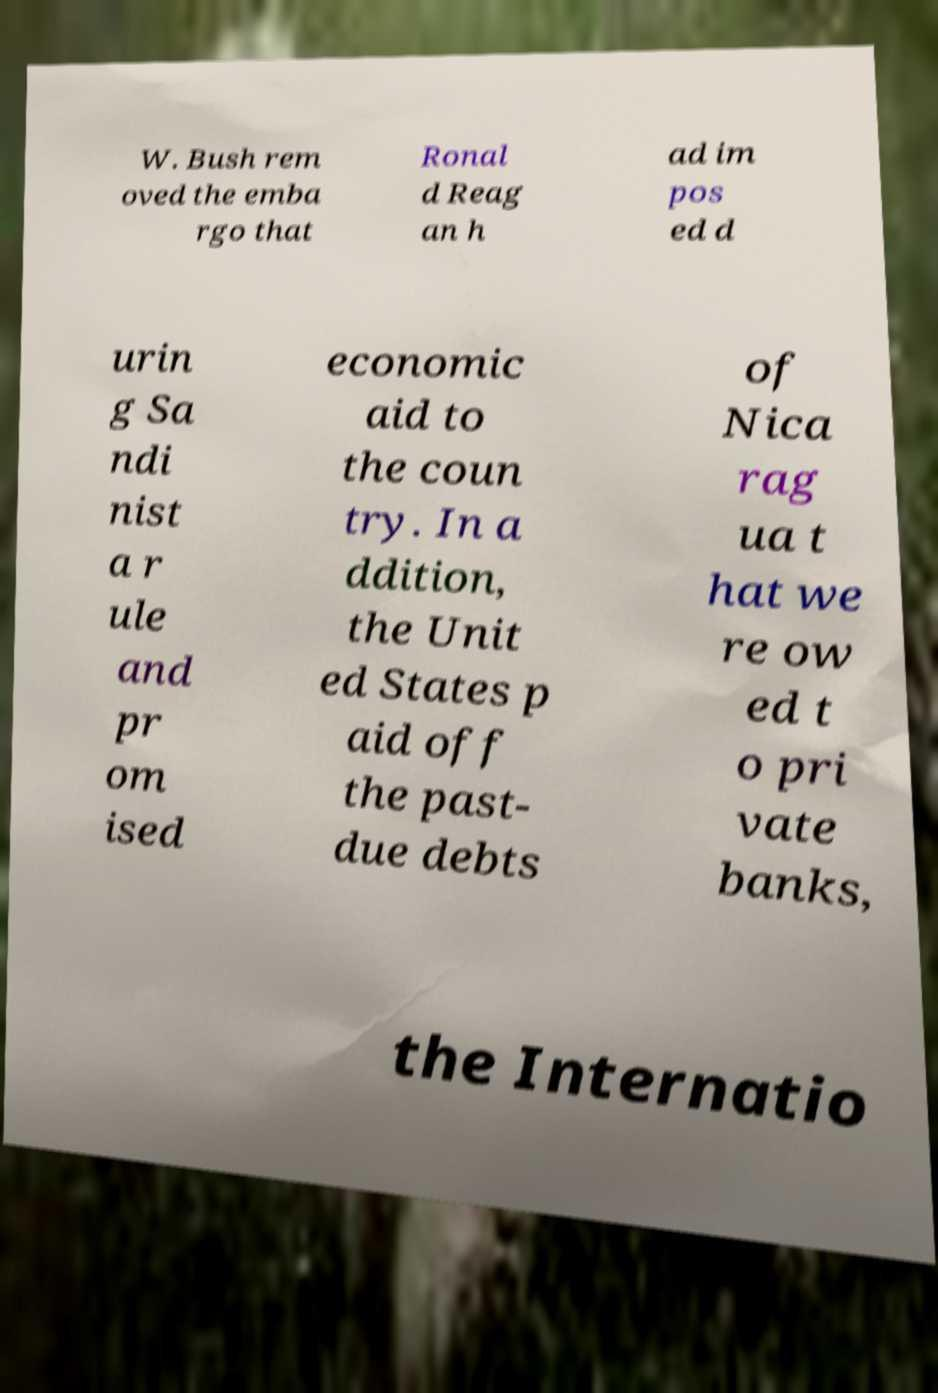I need the written content from this picture converted into text. Can you do that? W. Bush rem oved the emba rgo that Ronal d Reag an h ad im pos ed d urin g Sa ndi nist a r ule and pr om ised economic aid to the coun try. In a ddition, the Unit ed States p aid off the past- due debts of Nica rag ua t hat we re ow ed t o pri vate banks, the Internatio 